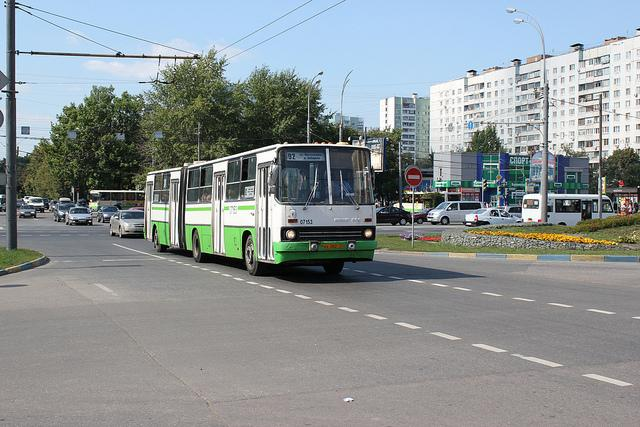What type setting is this roadway located in?

Choices:
A) rural
B) north pole
C) urban
D) tundra urban 